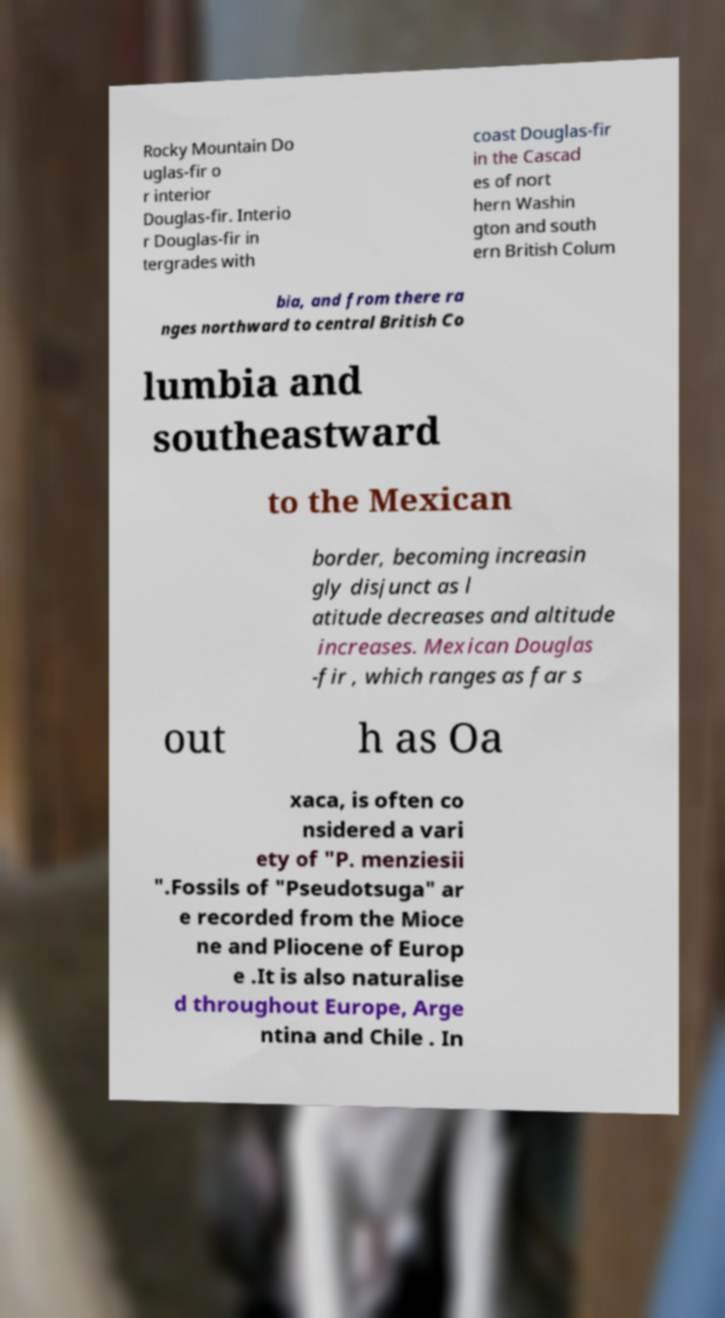Please read and relay the text visible in this image. What does it say? Rocky Mountain Do uglas-fir o r interior Douglas-fir. Interio r Douglas-fir in tergrades with coast Douglas-fir in the Cascad es of nort hern Washin gton and south ern British Colum bia, and from there ra nges northward to central British Co lumbia and southeastward to the Mexican border, becoming increasin gly disjunct as l atitude decreases and altitude increases. Mexican Douglas -fir , which ranges as far s out h as Oa xaca, is often co nsidered a vari ety of "P. menziesii ".Fossils of "Pseudotsuga" ar e recorded from the Mioce ne and Pliocene of Europ e .It is also naturalise d throughout Europe, Arge ntina and Chile . In 